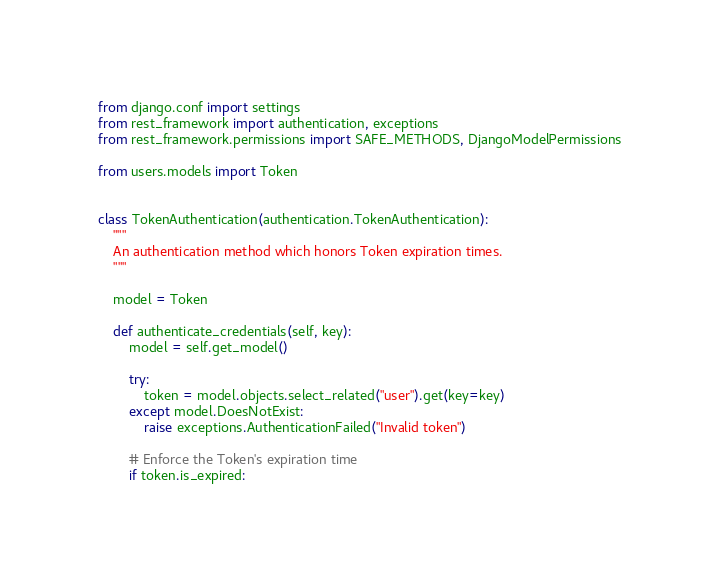<code> <loc_0><loc_0><loc_500><loc_500><_Python_>from django.conf import settings
from rest_framework import authentication, exceptions
from rest_framework.permissions import SAFE_METHODS, DjangoModelPermissions

from users.models import Token


class TokenAuthentication(authentication.TokenAuthentication):
    """
    An authentication method which honors Token expiration times.
    """

    model = Token

    def authenticate_credentials(self, key):
        model = self.get_model()

        try:
            token = model.objects.select_related("user").get(key=key)
        except model.DoesNotExist:
            raise exceptions.AuthenticationFailed("Invalid token")

        # Enforce the Token's expiration time
        if token.is_expired:</code> 